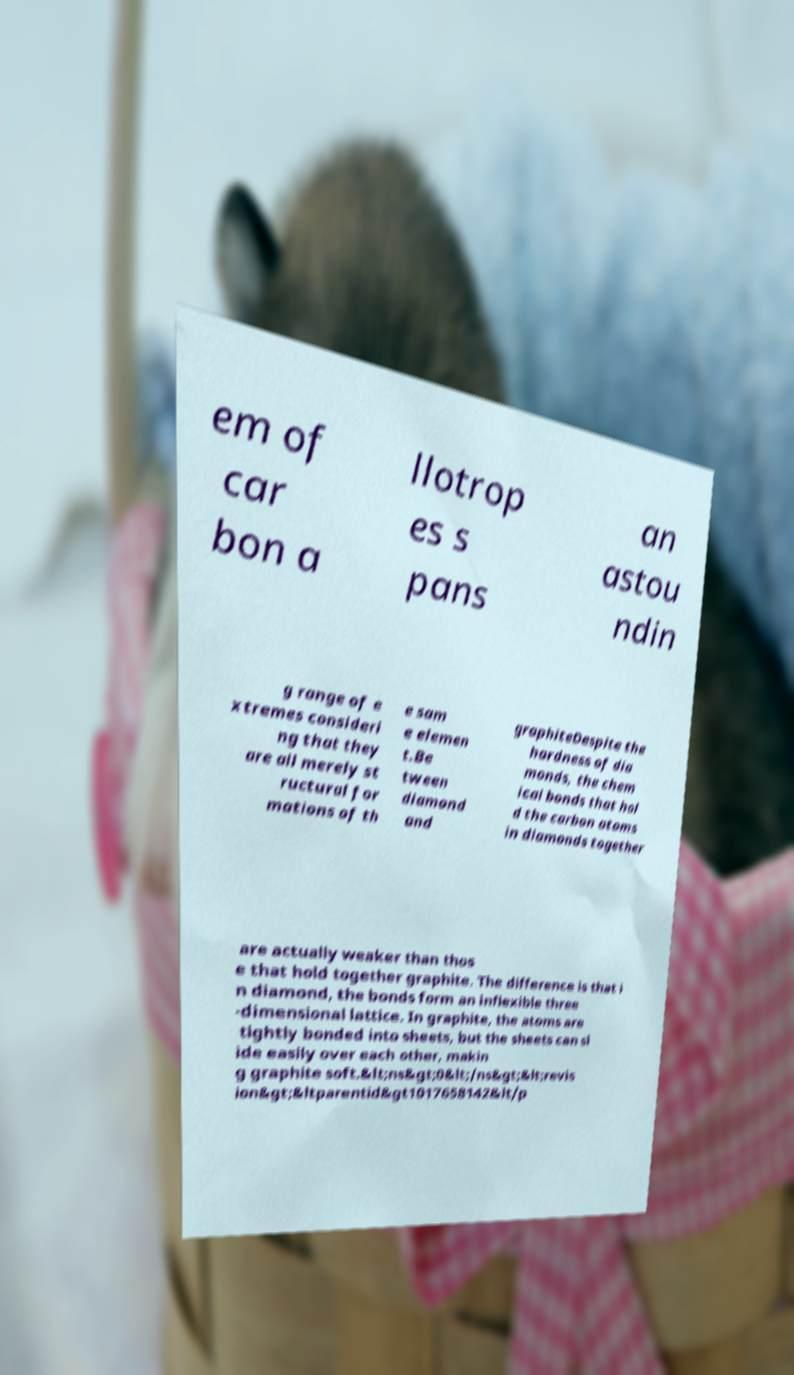Please read and relay the text visible in this image. What does it say? em of car bon a llotrop es s pans an astou ndin g range of e xtremes consideri ng that they are all merely st ructural for mations of th e sam e elemen t.Be tween diamond and graphiteDespite the hardness of dia monds, the chem ical bonds that hol d the carbon atoms in diamonds together are actually weaker than thos e that hold together graphite. The difference is that i n diamond, the bonds form an inflexible three -dimensional lattice. In graphite, the atoms are tightly bonded into sheets, but the sheets can sl ide easily over each other, makin g graphite soft.&lt;ns&gt;0&lt;/ns&gt;&lt;revis ion&gt;&ltparentid&gt1017658142&lt/p 